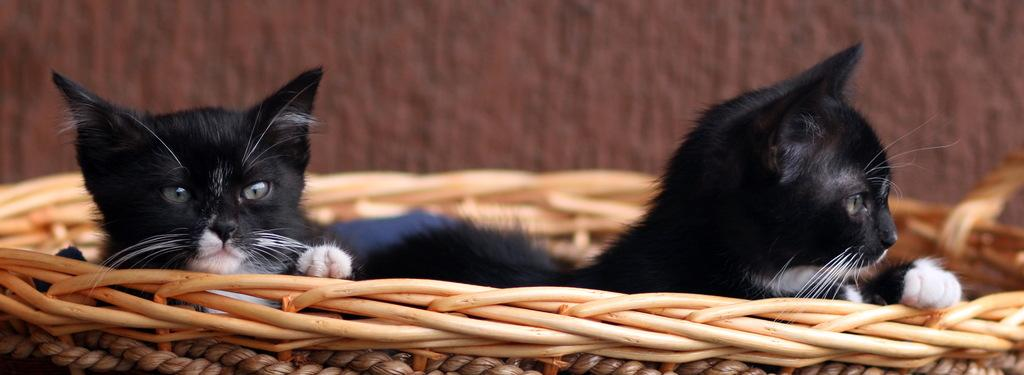What type of living organisms can be seen in the image? There are animals in the image. What color are the animals in the image? The animals are in black and white color. Where are the animals located in the image? The animals are in a wooden basket. What is the color of the background in the image? The background of the image is brown. What type of whistle can be heard coming from the animals in the image? There is no whistle present in the image, and the animals are not making any sounds. 